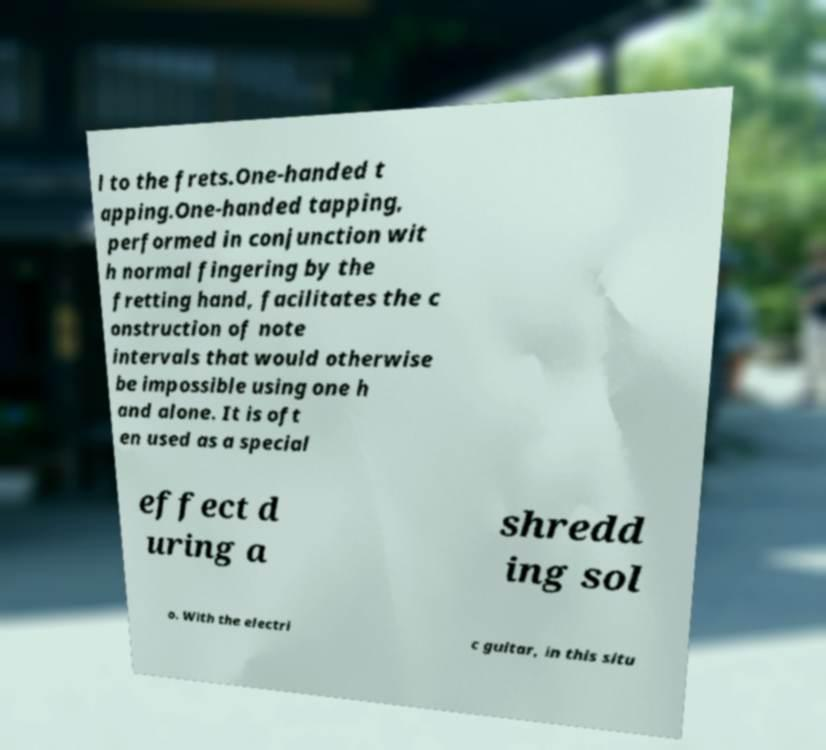Could you extract and type out the text from this image? l to the frets.One-handed t apping.One-handed tapping, performed in conjunction wit h normal fingering by the fretting hand, facilitates the c onstruction of note intervals that would otherwise be impossible using one h and alone. It is oft en used as a special effect d uring a shredd ing sol o. With the electri c guitar, in this situ 